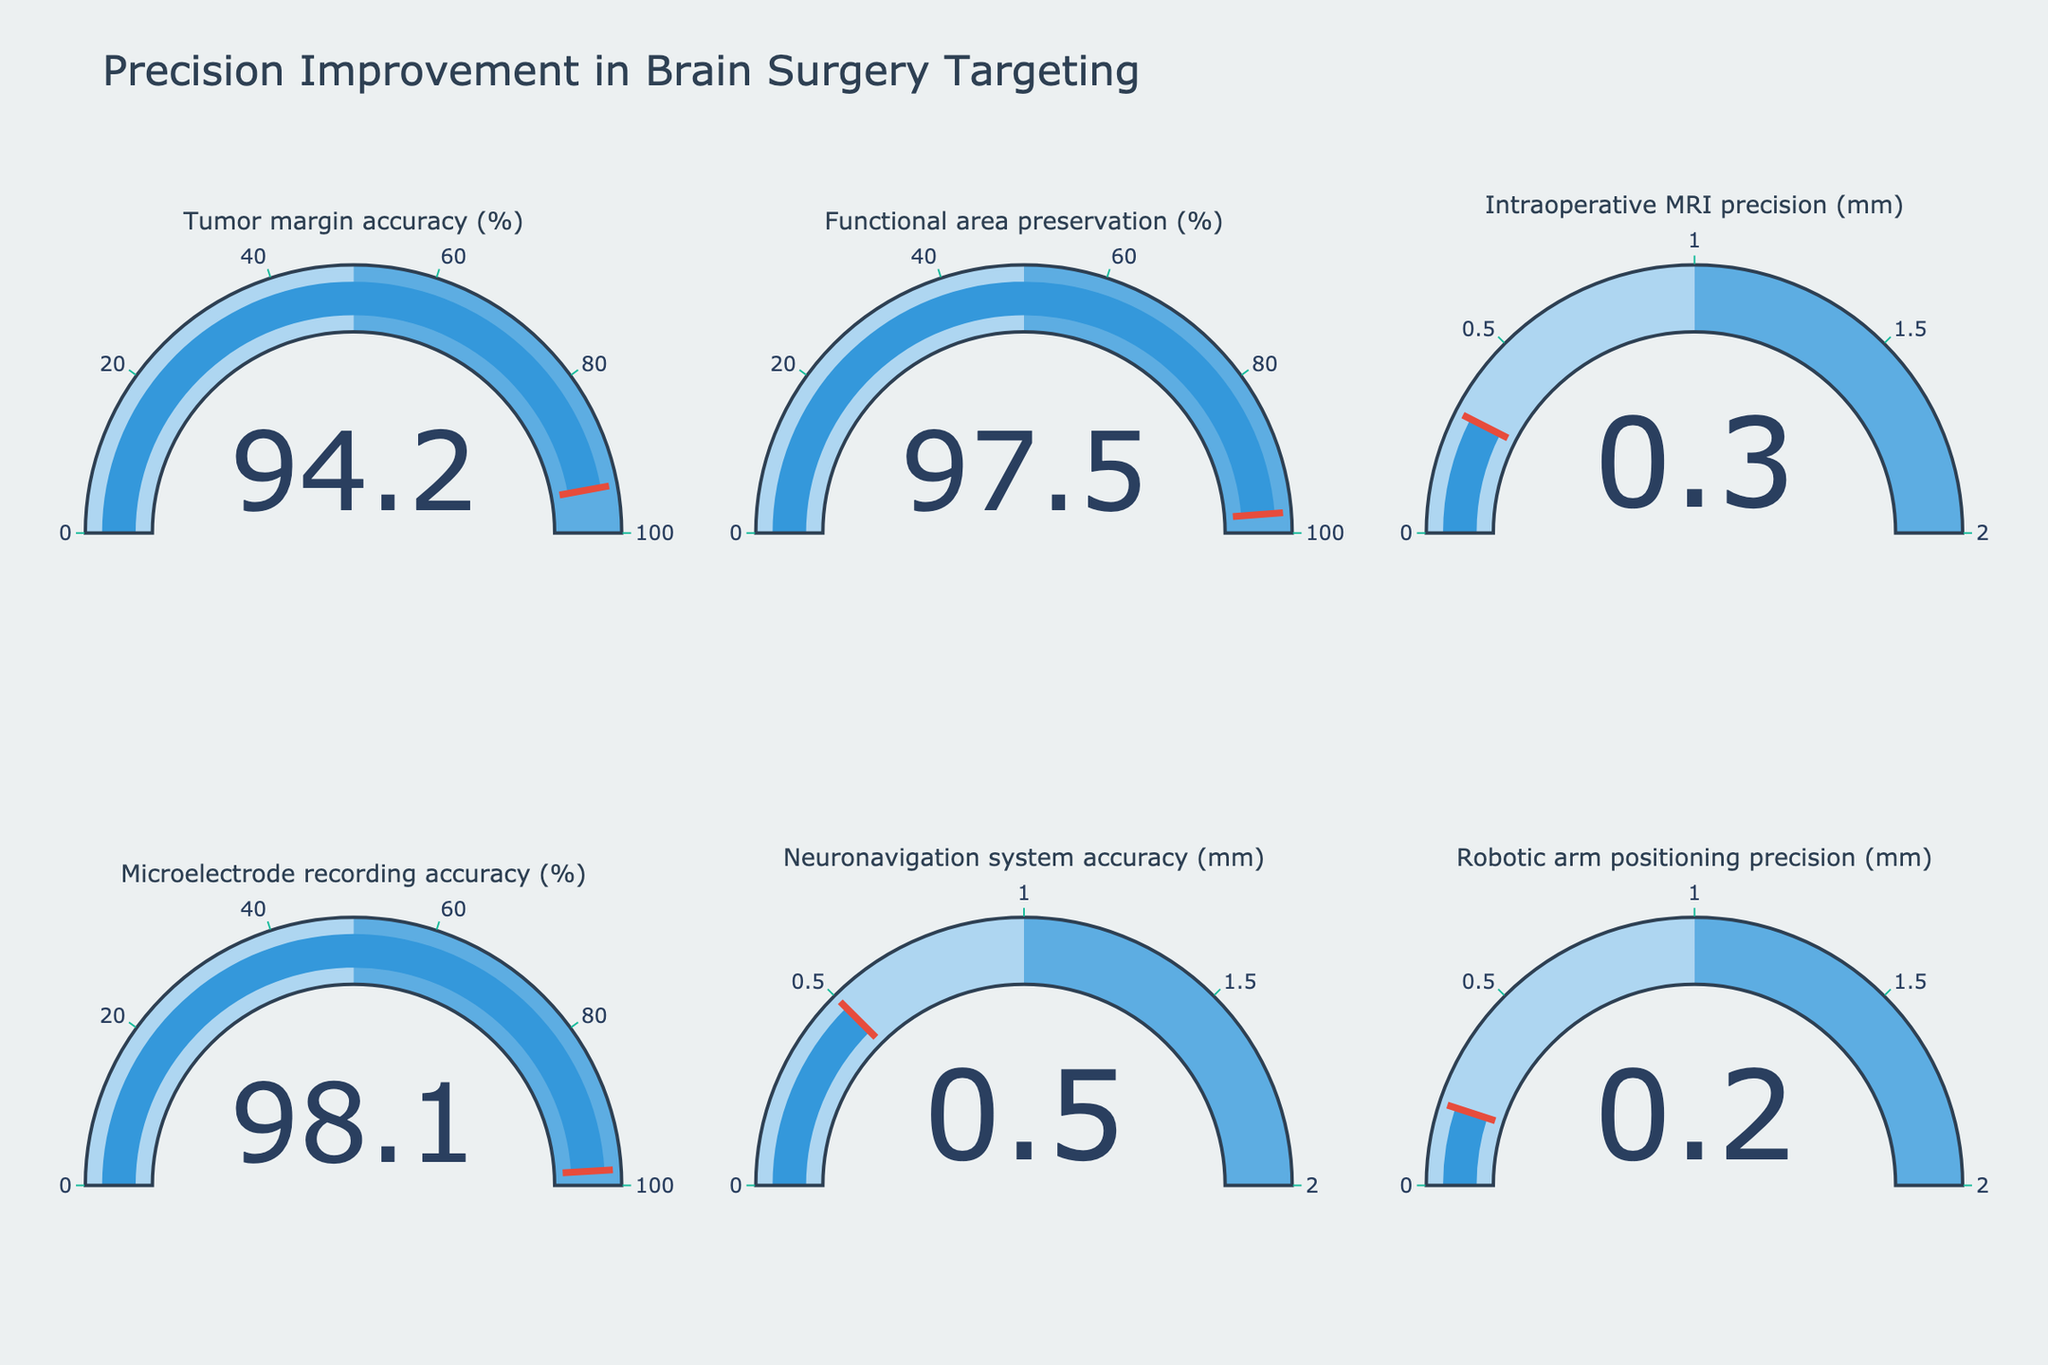what is the highest value among all the metrics? By looking at the gauge charts, identify the metric with the highest value. The "Microelectrode recording accuracy (%)" gauge shows the value 98.1%.
Answer: 98.1% How many gauge charts are presented in the figure? Count the total number of individual gauge charts displayed in the figure. By inspecting, there are 6 gauge charts.
Answer: 6 Which metric has the smallest value and what is it? Examine each gauge chart and identify the smallest value. The "Robotic arm positioning precision (mm)" has the smallest value, which is 0.2 mm.
Answer: 0.2 mm Are all recorded metrics that are measured in percentages above 95%? By inspecting the gauge charts, verify if each percentage metric is above 95%. The metrics "Tumor margin accuracy (%)", "Functional area preservation (%)", and "Microelectrode recording accuracy (%)" are all above 95%.
Answer: Yes What's the average accuracy over the percentage metrics? Calculate the average value of the percentage metrics. Sum the values (94.2 + 97.5 + 98.1) and divide by the number of percentage metrics (3). The average is (94.2 + 97.5 + 98.1)/3 = 96.6%.
Answer: 96.6% Which metric represents the highest precision in mm measurement? Compare the values of the metrics measured in millimeters and find the smallest value. "Robotic arm positioning precision (mm)" with a value of 0.2 mm is the highest precision.
Answer: Robotic arm positioning precision What is the difference in value between "Tumor margin accuracy (%)" and "Microelectrode recording accuracy (%)"? Subtract the value of the "Tumor margin accuracy (%)" from the "Microelectrode recording accuracy (%)". The difference is 98.1% - 94.2% = 3.9%.
Answer: 3.9% Which metrics have visuals that reach the threshold value on the gauge? Check the placement of the red threshold line on each gauge to verify if any values coincide with this mark. All metrics are below their threshold marks.
Answer: None 